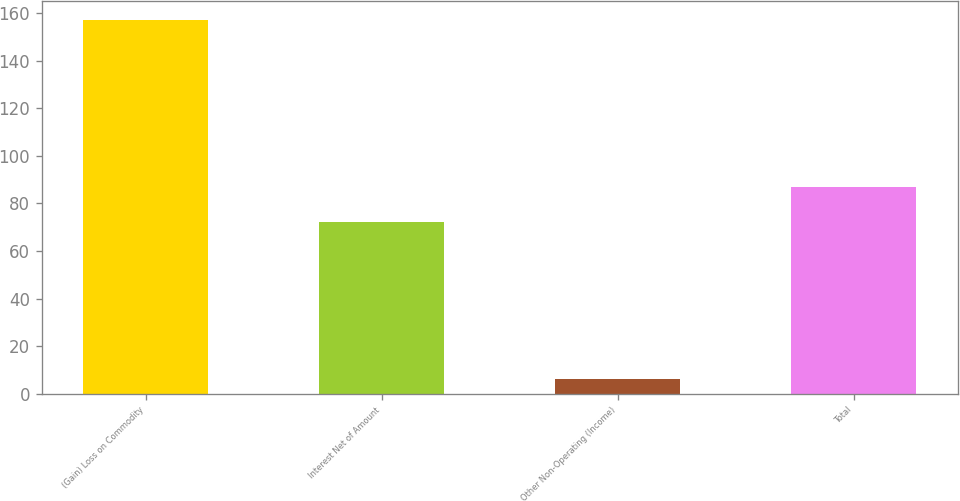<chart> <loc_0><loc_0><loc_500><loc_500><bar_chart><fcel>(Gain) Loss on Commodity<fcel>Interest Net of Amount<fcel>Other Non-Operating (Income)<fcel>Total<nl><fcel>157<fcel>72<fcel>6<fcel>87.1<nl></chart> 